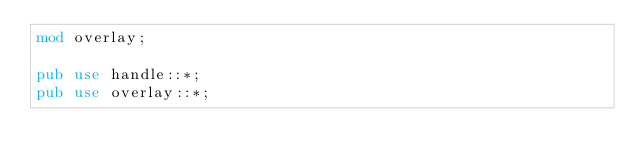<code> <loc_0><loc_0><loc_500><loc_500><_Rust_>mod overlay;

pub use handle::*;
pub use overlay::*;
</code> 